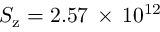Convert formula to latex. <formula><loc_0><loc_0><loc_500><loc_500>S _ { z } = 2 . 5 7 \, \times \, 1 0 ^ { 1 2 }</formula> 